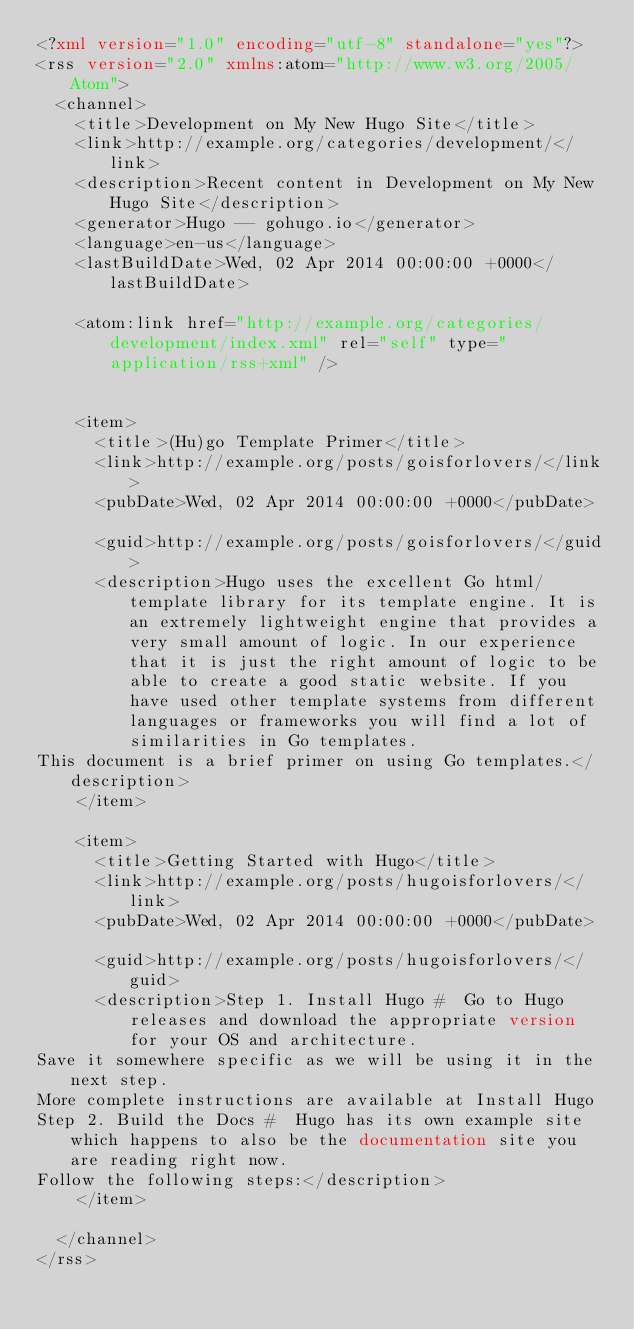<code> <loc_0><loc_0><loc_500><loc_500><_XML_><?xml version="1.0" encoding="utf-8" standalone="yes"?>
<rss version="2.0" xmlns:atom="http://www.w3.org/2005/Atom">
  <channel>
    <title>Development on My New Hugo Site</title>
    <link>http://example.org/categories/development/</link>
    <description>Recent content in Development on My New Hugo Site</description>
    <generator>Hugo -- gohugo.io</generator>
    <language>en-us</language>
    <lastBuildDate>Wed, 02 Apr 2014 00:00:00 +0000</lastBuildDate>
    
	<atom:link href="http://example.org/categories/development/index.xml" rel="self" type="application/rss+xml" />
    
    
    <item>
      <title>(Hu)go Template Primer</title>
      <link>http://example.org/posts/goisforlovers/</link>
      <pubDate>Wed, 02 Apr 2014 00:00:00 +0000</pubDate>
      
      <guid>http://example.org/posts/goisforlovers/</guid>
      <description>Hugo uses the excellent Go html/template library for its template engine. It is an extremely lightweight engine that provides a very small amount of logic. In our experience that it is just the right amount of logic to be able to create a good static website. If you have used other template systems from different languages or frameworks you will find a lot of similarities in Go templates.
This document is a brief primer on using Go templates.</description>
    </item>
    
    <item>
      <title>Getting Started with Hugo</title>
      <link>http://example.org/posts/hugoisforlovers/</link>
      <pubDate>Wed, 02 Apr 2014 00:00:00 +0000</pubDate>
      
      <guid>http://example.org/posts/hugoisforlovers/</guid>
      <description>Step 1. Install Hugo #  Go to Hugo releases and download the appropriate version for your OS and architecture.
Save it somewhere specific as we will be using it in the next step.
More complete instructions are available at Install Hugo
Step 2. Build the Docs #  Hugo has its own example site which happens to also be the documentation site you are reading right now.
Follow the following steps:</description>
    </item>
    
  </channel>
</rss></code> 